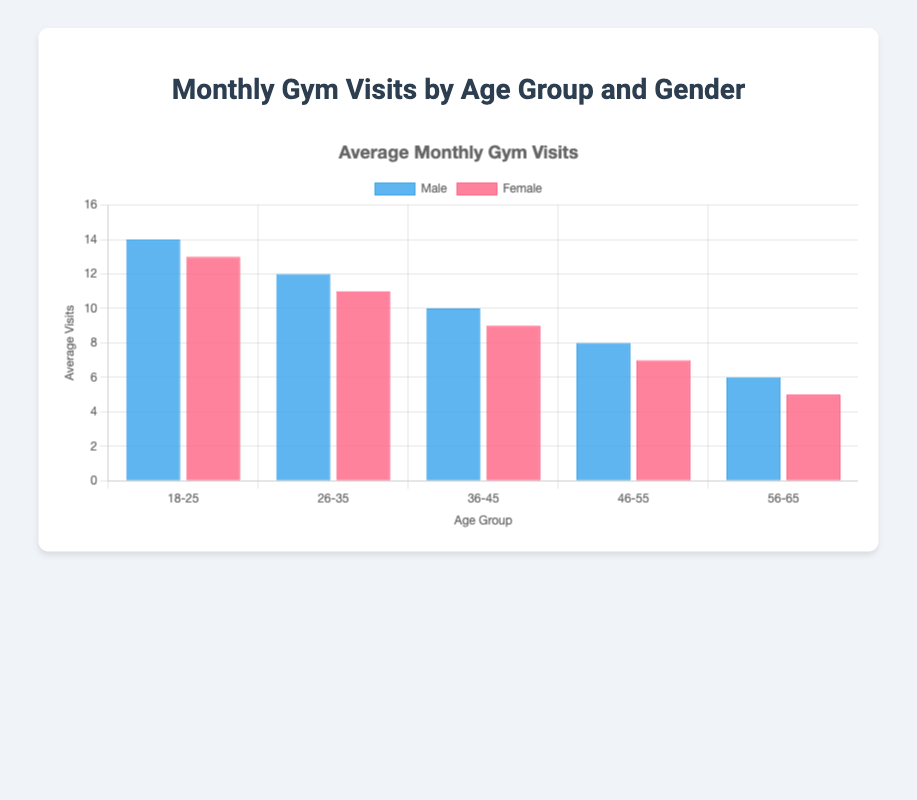What is the average number of gym visits for the 36-45 age group for both genders? To find the average number of gym visits for the 36-45 age group, sum the visits for both males and females, then divide by 2. (10 + 9) / 2 = 9.5
Answer: 9.5 Which gender visits the gym more frequently in the 26-35 age group? Compare the average visits for males and females in the 26-35 age group. Males have 12 visits, while females have 11 visits.
Answer: Male How much more frequently do males aged 18-25 visit the gym compared to females aged 46-55? Subtract the average visits of females aged 46-55 from the average visits of males aged 18-25. 14 - 7 = 7
Answer: 7 What is the total number of average visits for males across all age groups? Sum the average visits for males from all age groups: 14 (18-25) + 12 (26-35) + 10 (36-45) + 8 (46-55) + 6 (56-65) = 50
Answer: 50 Which age group has the smallest difference in gym visits between males and females? Calculate the difference in visits for each age group's males and females: (18-25: 14-13 = 1), (26-35: 12-11 = 1), (36-45: 10-9 = 1), (46-55: 8-7 = 1), (56-65: 6-5 = 1). All differences are 1, so the difference is smallest in all age groups.
Answer: All age groups In the 46-55 age group, do females visit the gym more or less often than males in the 56-65 age group? Compare the average visits for females in the 46-55 age group (7) with the average visits for males in the 56-65 age group (6). 7 is greater than 6.
Answer: More often How many more visits do males aged 18-25 make than males aged 56-65? Subtract the average visits of males aged 56-65 from the average visits of males aged 18-25. 14 - 6 = 8
Answer: 8 What's the difference in average gym visits between males and females across the youngest and oldest age groups (18-25, 56-65)? Calculate the differences in visits for the youngest age group (18-25) and the oldest (56-65): Youngest: 14 - 13 = 1, Oldest: 6 - 5 = 1. Then find the total difference. 1 + 1 = 2.
Answer: 2 Among all the displayed groups, which age group has the least male gym visits? Identify the age group with the smallest number of average male visits. The numbers are 14, 12, 10, 8, and 6. The smallest is 6. The age group is 56-65.
Answer: 56-65 